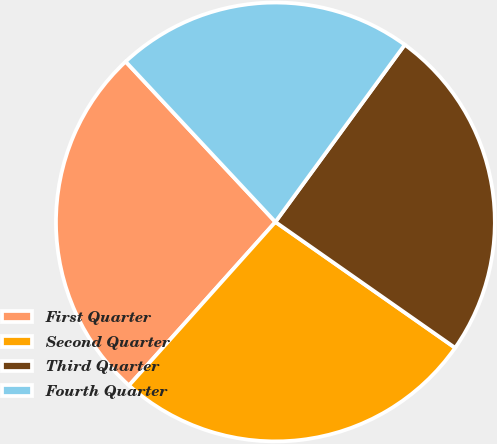Convert chart. <chart><loc_0><loc_0><loc_500><loc_500><pie_chart><fcel>First Quarter<fcel>Second Quarter<fcel>Third Quarter<fcel>Fourth Quarter<nl><fcel>26.42%<fcel>26.9%<fcel>24.69%<fcel>21.99%<nl></chart> 